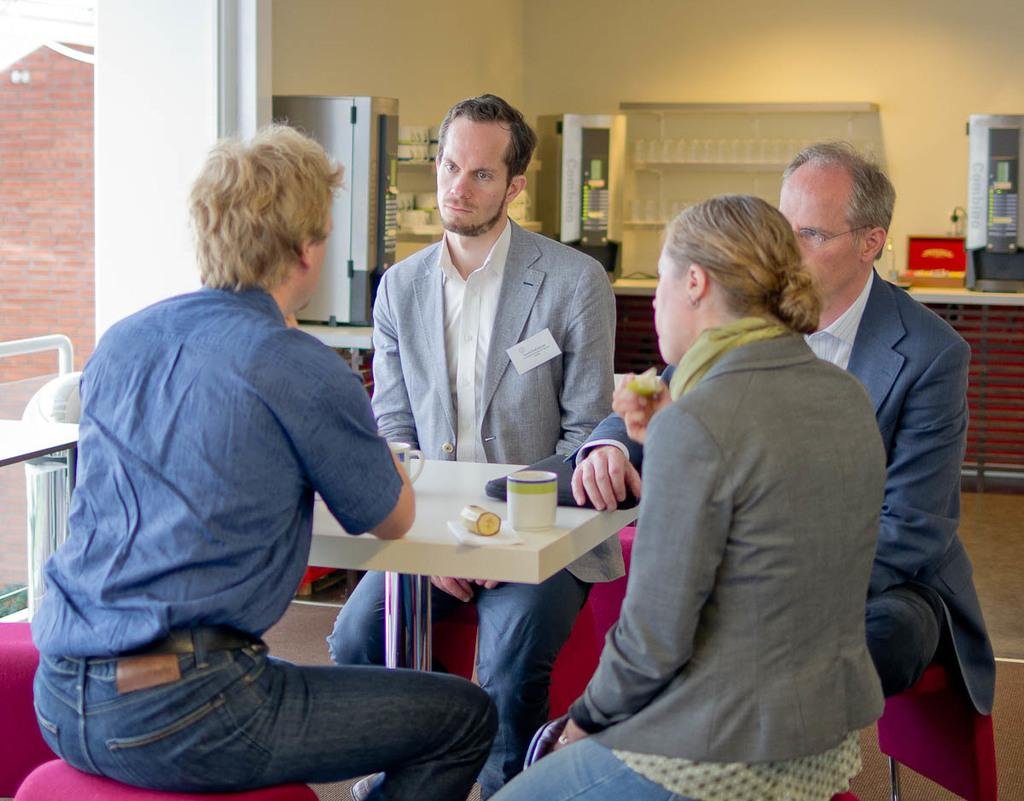How many people are present in the image? There are four people in the image. What are the people doing in the image? The people are sitting around a table and discussing between them. What can be seen on the table in the image? There is a cup on the table. What is visible in the background of the image? There is a wall and a shelf in the background. What is on the shelf in the background? The shelf is full of glasses and cups. What sound can be heard coming from the heart of the person in the image? There is no sound or heart visible in the image; it only shows four people sitting around a table and discussing. 